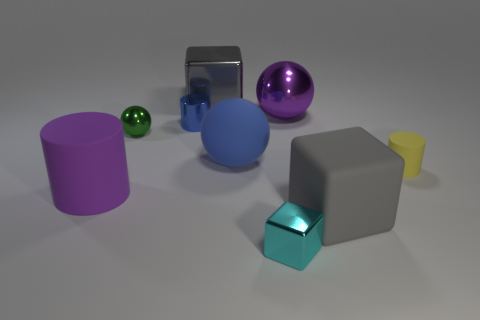Is the big shiny ball the same color as the big rubber sphere? No, they are not the same color. The big shiny ball appears to have a purplish hue, while the rubber sphere is a matte blue color. The difference in material and finish between the two objects further accentuates their distinct colors. 